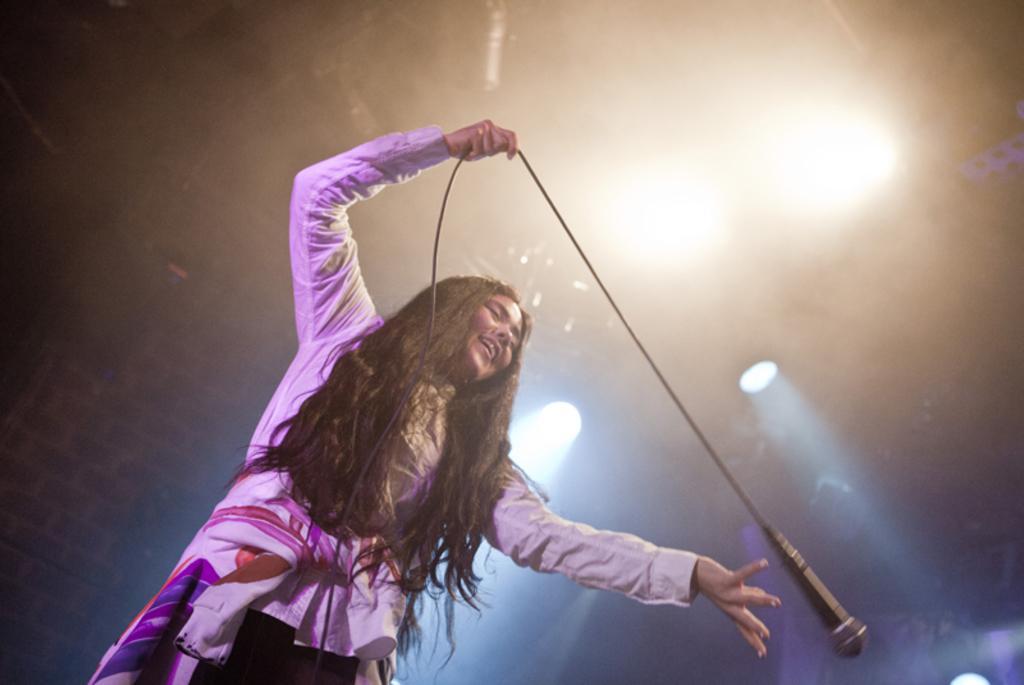Could you give a brief overview of what you see in this image? In this image I can see there is a woman standing and she is holding a microphone and there are few lights attached to the ceiling. 